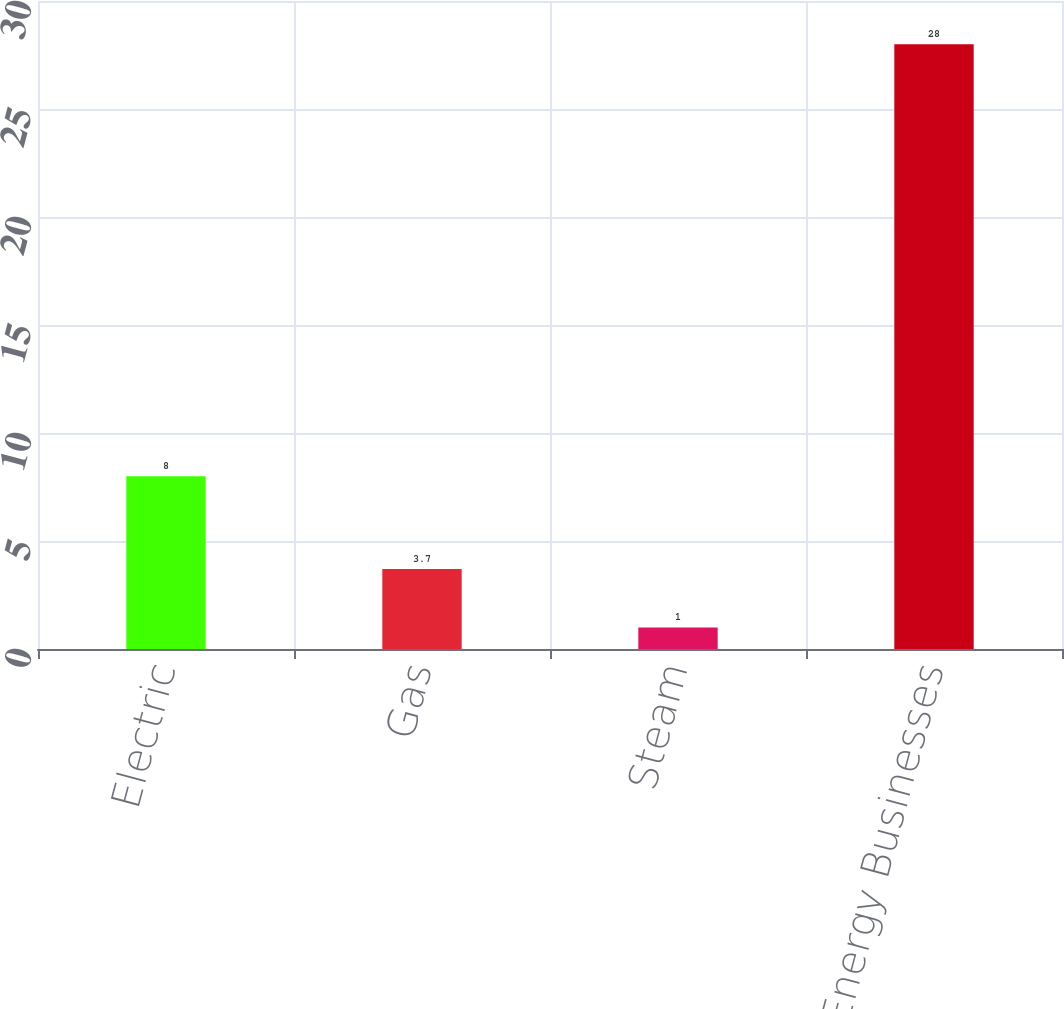Convert chart. <chart><loc_0><loc_0><loc_500><loc_500><bar_chart><fcel>Electric<fcel>Gas<fcel>Steam<fcel>Clean Energy Businesses<nl><fcel>8<fcel>3.7<fcel>1<fcel>28<nl></chart> 